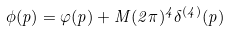Convert formula to latex. <formula><loc_0><loc_0><loc_500><loc_500>\phi ( p ) = \varphi ( p ) + M ( 2 \pi ) ^ { 4 } \delta ^ { ( 4 ) } ( p )</formula> 